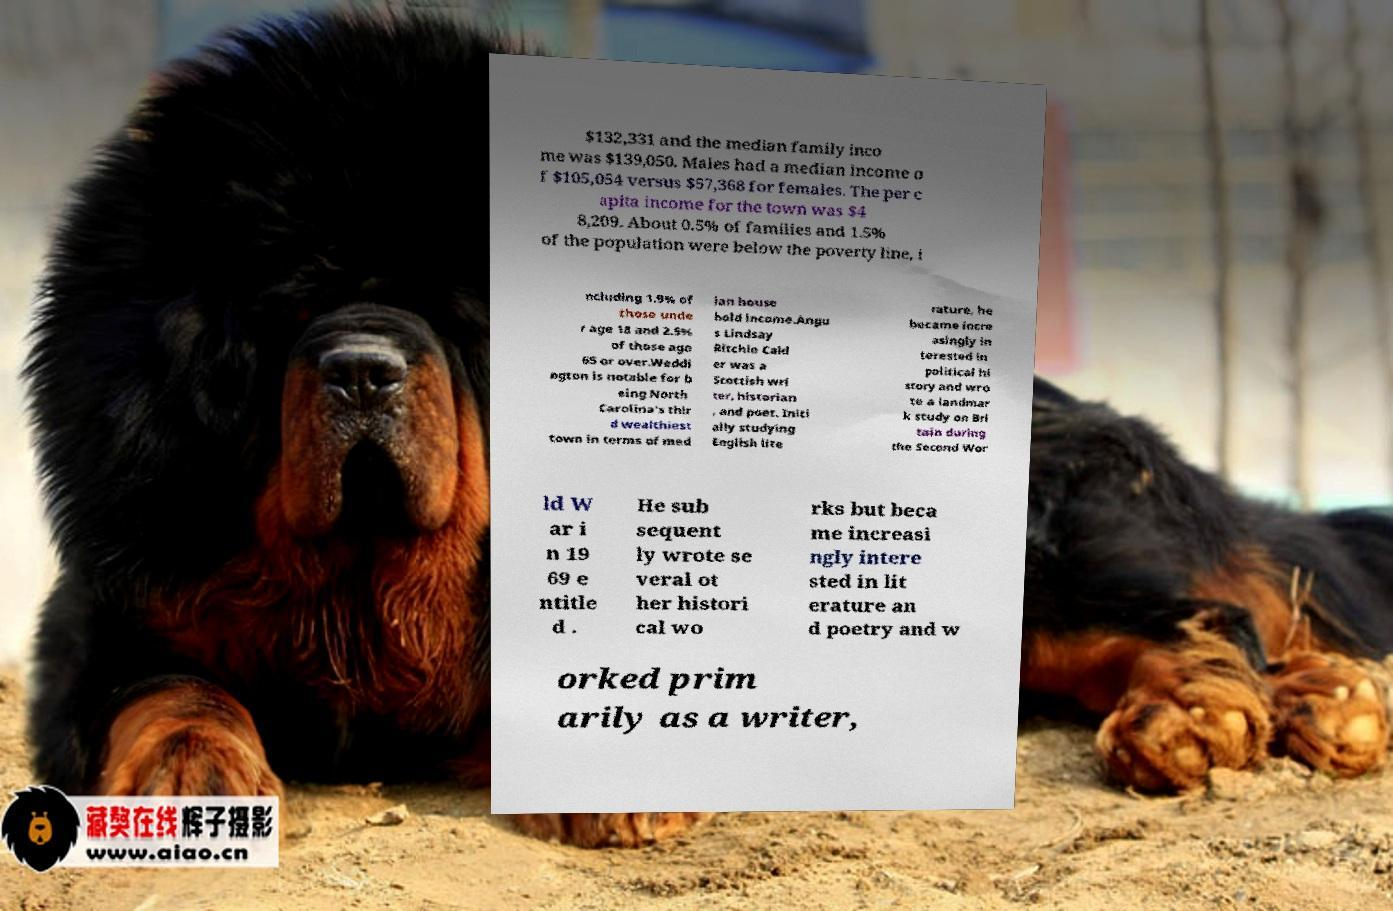Please read and relay the text visible in this image. What does it say? $132,331 and the median family inco me was $139,050. Males had a median income o f $105,054 versus $57,368 for females. The per c apita income for the town was $4 8,209. About 0.5% of families and 1.5% of the population were below the poverty line, i ncluding 1.9% of those unde r age 18 and 2.5% of those age 65 or over.Weddi ngton is notable for b eing North Carolina's thir d wealthiest town in terms of med ian house hold income.Angu s Lindsay Ritchie Cald er was a Scottish wri ter, historian , and poet. Initi ally studying English lite rature, he became incre asingly in terested in political hi story and wro te a landmar k study on Bri tain during the Second Wor ld W ar i n 19 69 e ntitle d . He sub sequent ly wrote se veral ot her histori cal wo rks but beca me increasi ngly intere sted in lit erature an d poetry and w orked prim arily as a writer, 